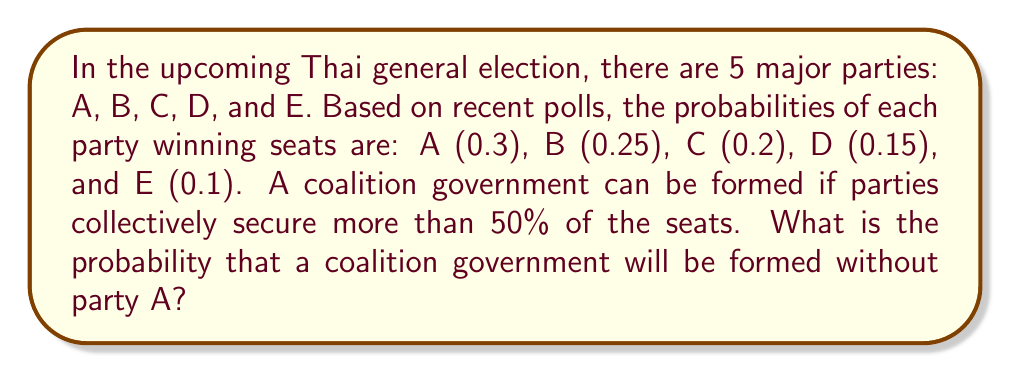Show me your answer to this math problem. To solve this problem, we need to use the concept of probability and combinations. Let's approach this step-by-step:

1) First, we need to consider all possible combinations of parties that can form a coalition without party A. These are:
   - B + C + D + E
   - B + C + D
   - B + C + E
   - B + D + E
   - C + D + E

2) Now, we need to calculate the probability of each combination:

   a) P(B + C + D + E) = 0.25 * 0.2 * 0.15 * 0.1 = 0.00075
   
   b) P(B + C + D) = 0.25 * 0.2 * 0.15 * (1 - 0.1) = 0.00675
   
   c) P(B + C + E) = 0.25 * 0.2 * (1 - 0.15) * 0.1 = 0.00425
   
   d) P(B + D + E) = 0.25 * (1 - 0.2) * 0.15 * 0.1 = 0.003
   
   e) P(C + D + E) = (1 - 0.25) * 0.2 * 0.15 * 0.1 = 0.00225

3) The total probability is the sum of all these individual probabilities:

   $$P(\text{coalition without A}) = 0.00075 + 0.00675 + 0.00425 + 0.003 + 0.00225 = 0.017$$

4) Therefore, the probability of forming a coalition government without party A is 0.017 or 1.7%.
Answer: 0.017 